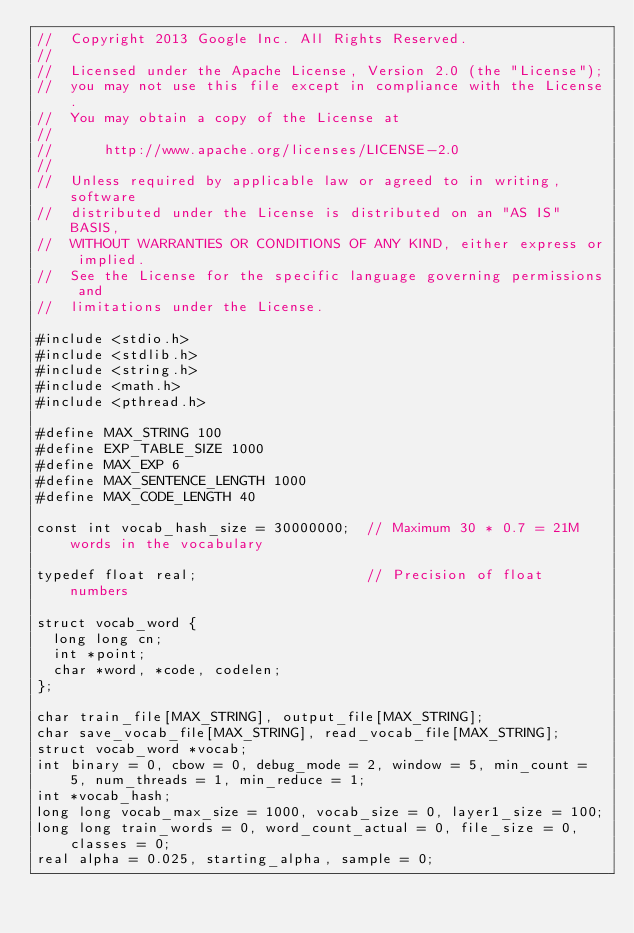Convert code to text. <code><loc_0><loc_0><loc_500><loc_500><_C_>//  Copyright 2013 Google Inc. All Rights Reserved.
//
//  Licensed under the Apache License, Version 2.0 (the "License");
//  you may not use this file except in compliance with the License.
//  You may obtain a copy of the License at
//
//      http://www.apache.org/licenses/LICENSE-2.0
//
//  Unless required by applicable law or agreed to in writing, software
//  distributed under the License is distributed on an "AS IS" BASIS,
//  WITHOUT WARRANTIES OR CONDITIONS OF ANY KIND, either express or implied.
//  See the License for the specific language governing permissions and
//  limitations under the License.

#include <stdio.h>
#include <stdlib.h>
#include <string.h>
#include <math.h>
#include <pthread.h>

#define MAX_STRING 100
#define EXP_TABLE_SIZE 1000
#define MAX_EXP 6
#define MAX_SENTENCE_LENGTH 1000
#define MAX_CODE_LENGTH 40

const int vocab_hash_size = 30000000;  // Maximum 30 * 0.7 = 21M words in the vocabulary

typedef float real;                    // Precision of float numbers

struct vocab_word {
  long long cn;
  int *point;
  char *word, *code, codelen;
};

char train_file[MAX_STRING], output_file[MAX_STRING];
char save_vocab_file[MAX_STRING], read_vocab_file[MAX_STRING];
struct vocab_word *vocab;
int binary = 0, cbow = 0, debug_mode = 2, window = 5, min_count = 5, num_threads = 1, min_reduce = 1;
int *vocab_hash;
long long vocab_max_size = 1000, vocab_size = 0, layer1_size = 100;
long long train_words = 0, word_count_actual = 0, file_size = 0, classes = 0;
real alpha = 0.025, starting_alpha, sample = 0;</code> 